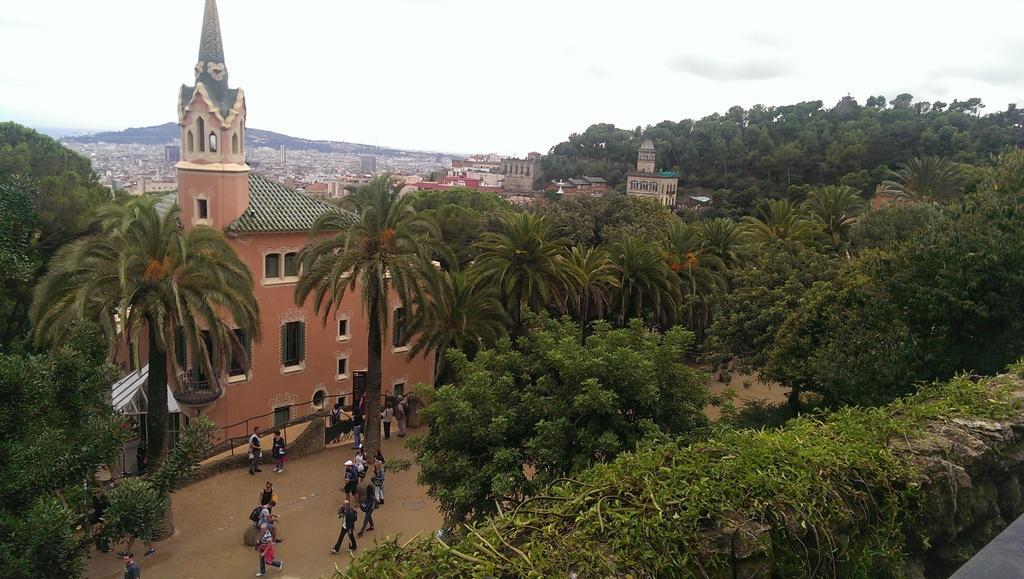Can you describe this image briefly? In this picture I can see trees. I can see the buildings. I can see people on the surface. I can see clouds in the sky. 